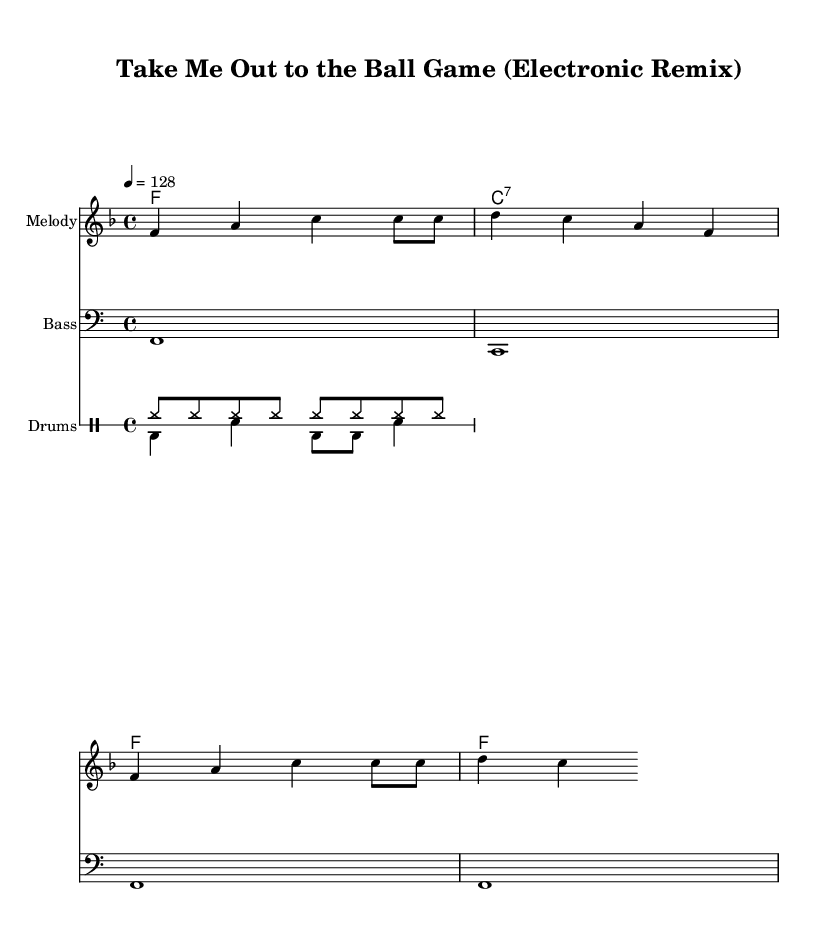What is the key signature of this music? The key signature is F major, which has one flat (B flat). This can be determined by looking at the key signature section at the beginning of the staff.
Answer: F major What is the time signature of this music? The time signature is 4/4, as indicated at the start of the sheet music. This means there are four beats in each measure, and the quarter note gets one beat.
Answer: 4/4 What is the tempo marking for this arrangement? The tempo marking indicates that the piece should be played at a speed of 128 beats per minute. This is explicitly stated in the tempo section near the top of the score.
Answer: 128 How many measures are in the melody section? The melody consists of four measures. By counting the number of sections separated by vertical lines, we can clearly see the total.
Answer: 4 What is the bass clef used for in this music? The bass clef is used to denote lower pitches, typically for bass instruments. In this score, it has been specified to display the bass rhythm and melody.
Answer: Bass What distinct electronic element is used in the drum pattern? The drum pattern features a combination of hihat and bass drum sounds, which is typical in electronic remixes. The repeated hihat creates a consistent rhythm, characteristic of electronic music.
Answer: Hihat What is the overall genre of this arrangement? The arrangement falls under the electronic genre, as indicated in the original title and its upbeat remix style of a classic baseball anthem.
Answer: Electronic 